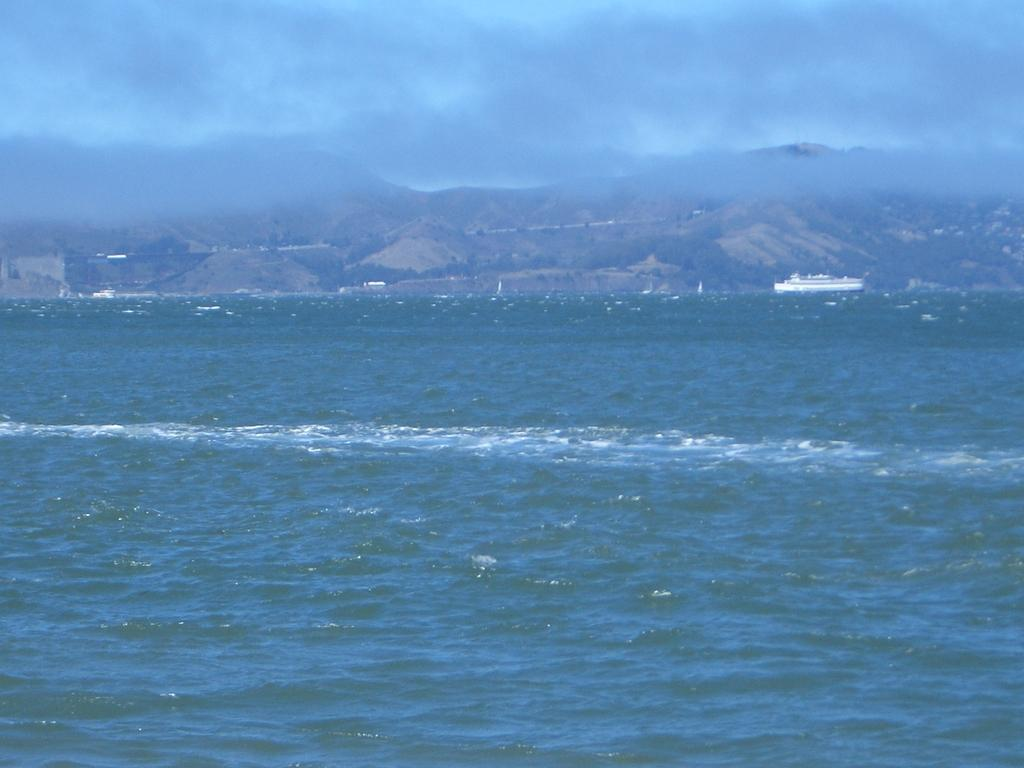What is the main subject of the image? The main subject of the image is a boat. Where is the boat located? The boat is on water. What can be seen in the background of the image? There are mountains and the sky visible in the background of the image. What is the condition of the sky in the image? The sky has clouds present in it. How does the boat stretch its sails in the image? The boat does not stretch its sails in the image; there is no indication of the boat being in motion or having sails. 